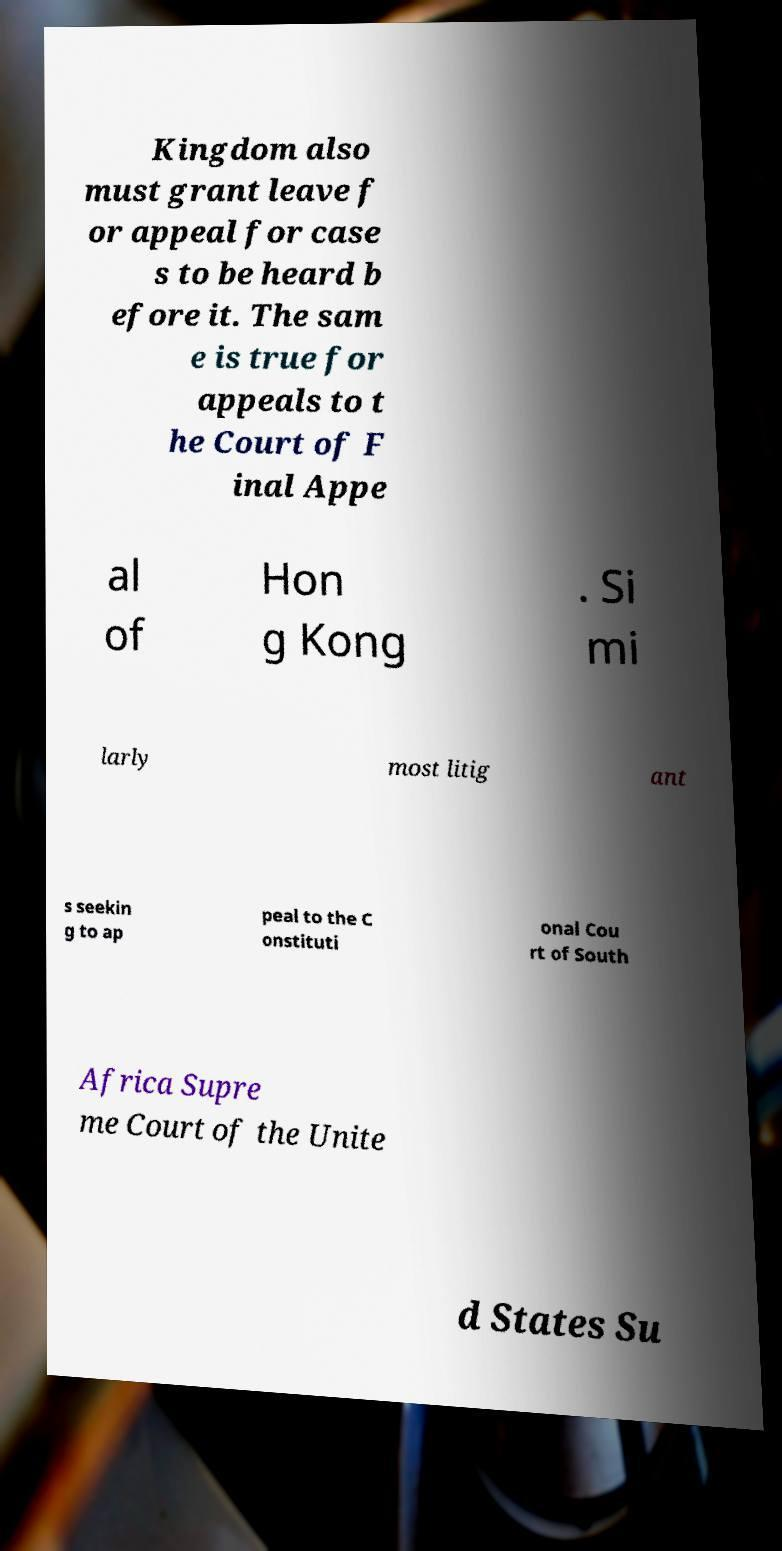For documentation purposes, I need the text within this image transcribed. Could you provide that? Kingdom also must grant leave f or appeal for case s to be heard b efore it. The sam e is true for appeals to t he Court of F inal Appe al of Hon g Kong . Si mi larly most litig ant s seekin g to ap peal to the C onstituti onal Cou rt of South Africa Supre me Court of the Unite d States Su 